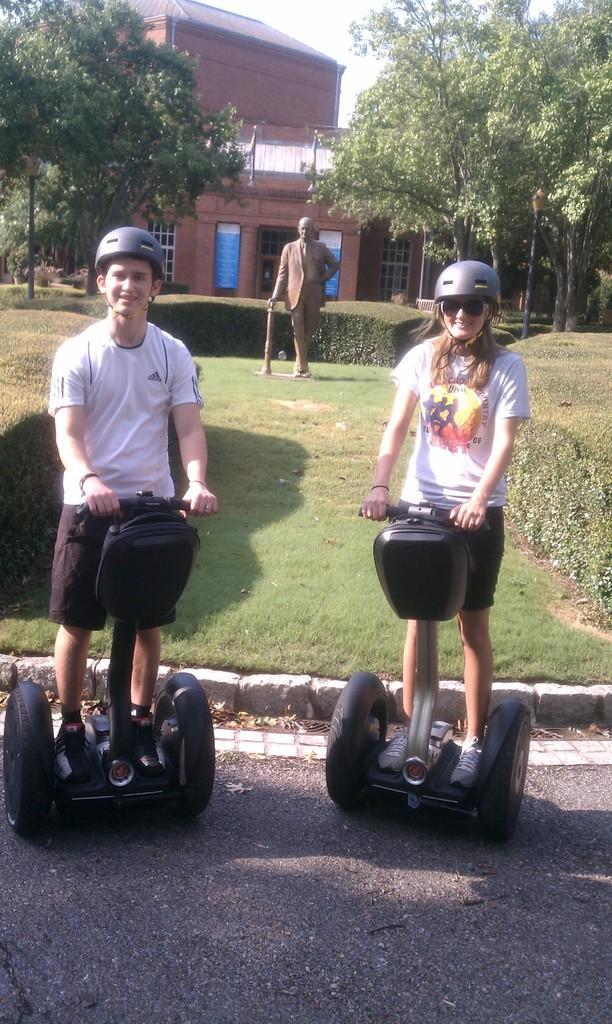Can you describe this image briefly? In this image we can see two people standing on the skating board. In the background there is a sculpture and we can see buildings. There are trees. We can see hedges. There is sky. 